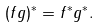Convert formula to latex. <formula><loc_0><loc_0><loc_500><loc_500>( f g ) ^ { * } = f ^ { * } g ^ { * } .</formula> 